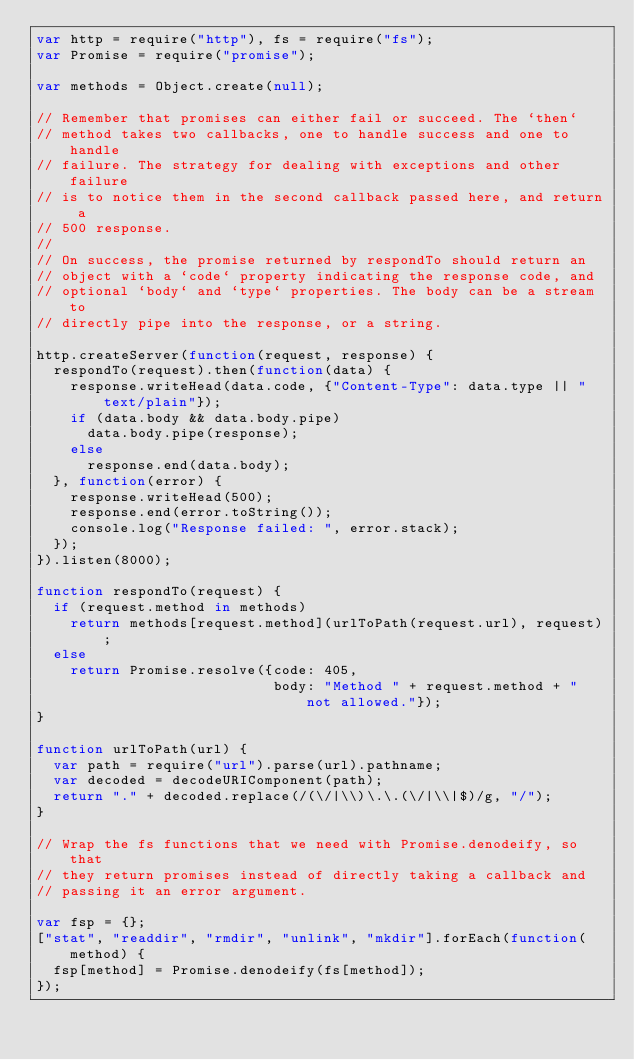Convert code to text. <code><loc_0><loc_0><loc_500><loc_500><_JavaScript_>var http = require("http"), fs = require("fs");
var Promise = require("promise");

var methods = Object.create(null);

// Remember that promises can either fail or succeed. The `then`
// method takes two callbacks, one to handle success and one to handle
// failure. The strategy for dealing with exceptions and other failure
// is to notice them in the second callback passed here, and return a
// 500 response.
//
// On success, the promise returned by respondTo should return an
// object with a `code` property indicating the response code, and
// optional `body` and `type` properties. The body can be a stream to
// directly pipe into the response, or a string.

http.createServer(function(request, response) {
  respondTo(request).then(function(data) {
    response.writeHead(data.code, {"Content-Type": data.type || "text/plain"});
    if (data.body && data.body.pipe)
      data.body.pipe(response);
    else
      response.end(data.body);
  }, function(error) {
    response.writeHead(500);
    response.end(error.toString());
    console.log("Response failed: ", error.stack);
  });
}).listen(8000);

function respondTo(request) {
  if (request.method in methods)
    return methods[request.method](urlToPath(request.url), request);
  else
    return Promise.resolve({code: 405,
                            body: "Method " + request.method + " not allowed."});
}

function urlToPath(url) {
  var path = require("url").parse(url).pathname;
  var decoded = decodeURIComponent(path);
  return "." + decoded.replace(/(\/|\\)\.\.(\/|\\|$)/g, "/");
}

// Wrap the fs functions that we need with Promise.denodeify, so that
// they return promises instead of directly taking a callback and
// passing it an error argument.

var fsp = {};
["stat", "readdir", "rmdir", "unlink", "mkdir"].forEach(function(method) {
  fsp[method] = Promise.denodeify(fs[method]);
});
</code> 